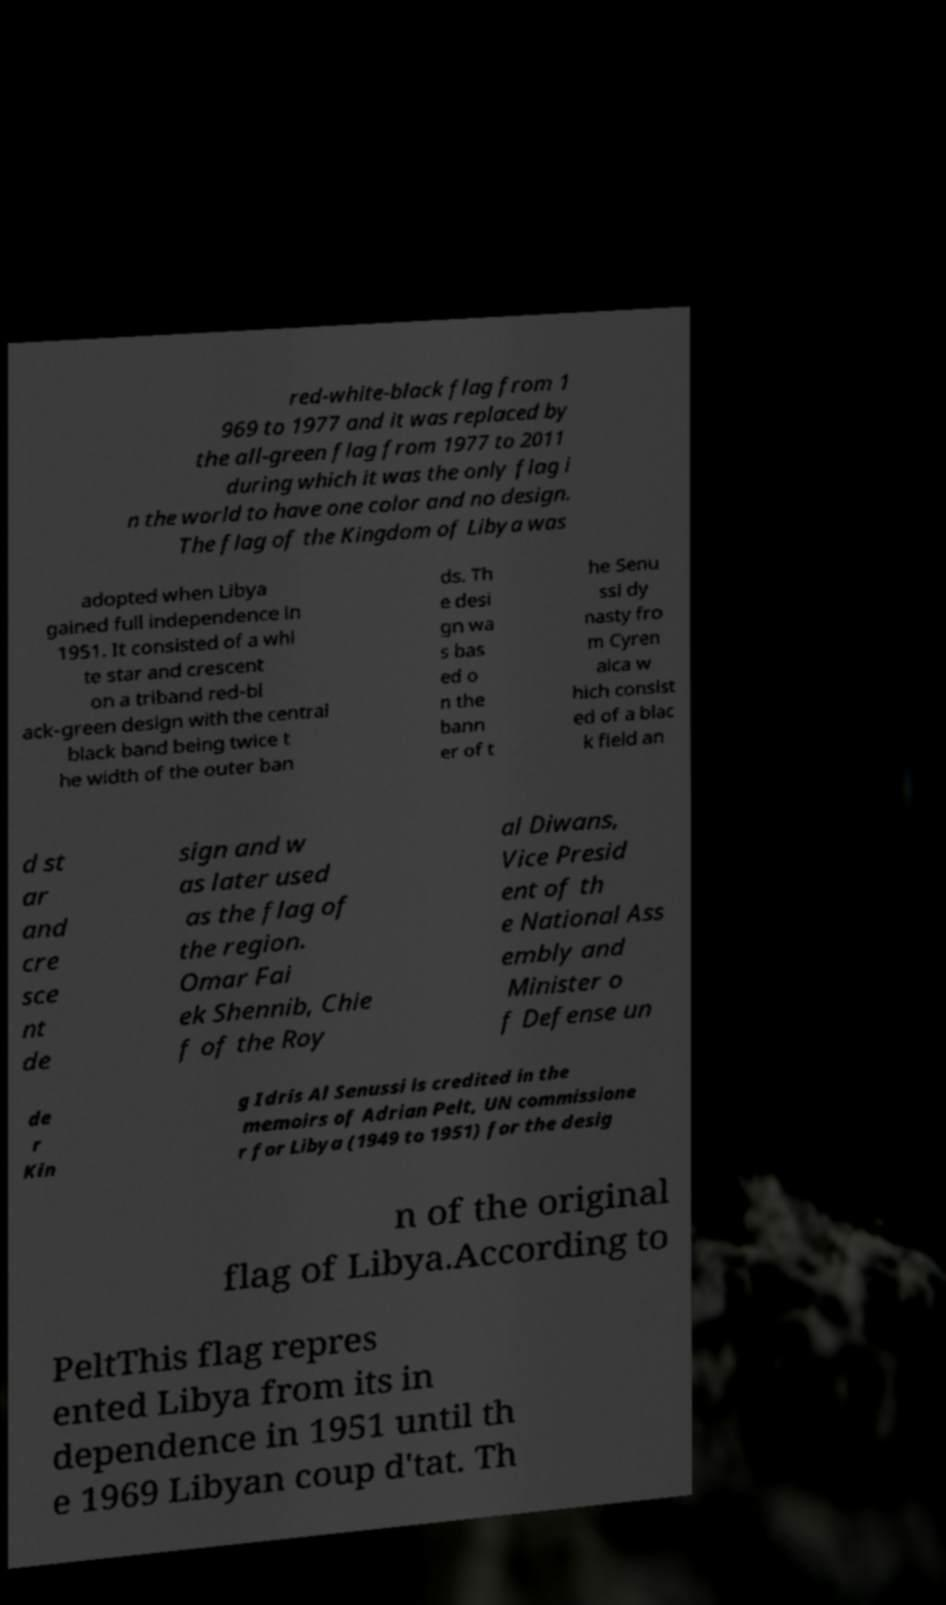Could you assist in decoding the text presented in this image and type it out clearly? red-white-black flag from 1 969 to 1977 and it was replaced by the all-green flag from 1977 to 2011 during which it was the only flag i n the world to have one color and no design. The flag of the Kingdom of Libya was adopted when Libya gained full independence in 1951. It consisted of a whi te star and crescent on a triband red-bl ack-green design with the central black band being twice t he width of the outer ban ds. Th e desi gn wa s bas ed o n the bann er of t he Senu ssi dy nasty fro m Cyren aica w hich consist ed of a blac k field an d st ar and cre sce nt de sign and w as later used as the flag of the region. Omar Fai ek Shennib, Chie f of the Roy al Diwans, Vice Presid ent of th e National Ass embly and Minister o f Defense un de r Kin g Idris Al Senussi is credited in the memoirs of Adrian Pelt, UN commissione r for Libya (1949 to 1951) for the desig n of the original flag of Libya.According to PeltThis flag repres ented Libya from its in dependence in 1951 until th e 1969 Libyan coup d'tat. Th 